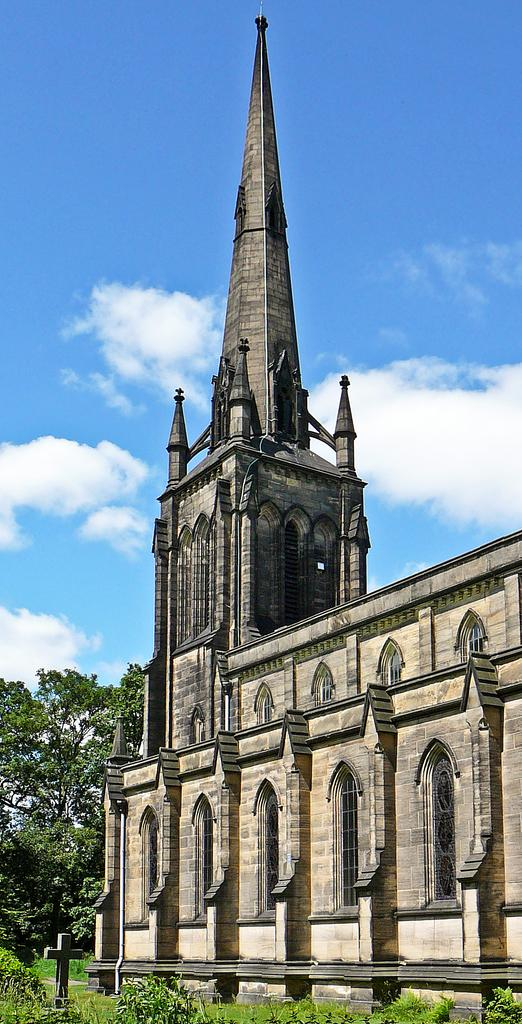What religious symbol is present in the image? There is a cross in the image. What type of vegetation can be seen in the image? There are plants and trees in the image. What type of structure is visible in the image? There is a building with windows in the image. What is visible in the background of the image? The sky with clouds is visible in the background of the image. How many balloons are tied to the cross in the image? There are no balloons present in the image; it only features a cross, plants, trees, a building, and the sky. What type of cattle can be seen grazing in the image? There is no cattle present in the image. 